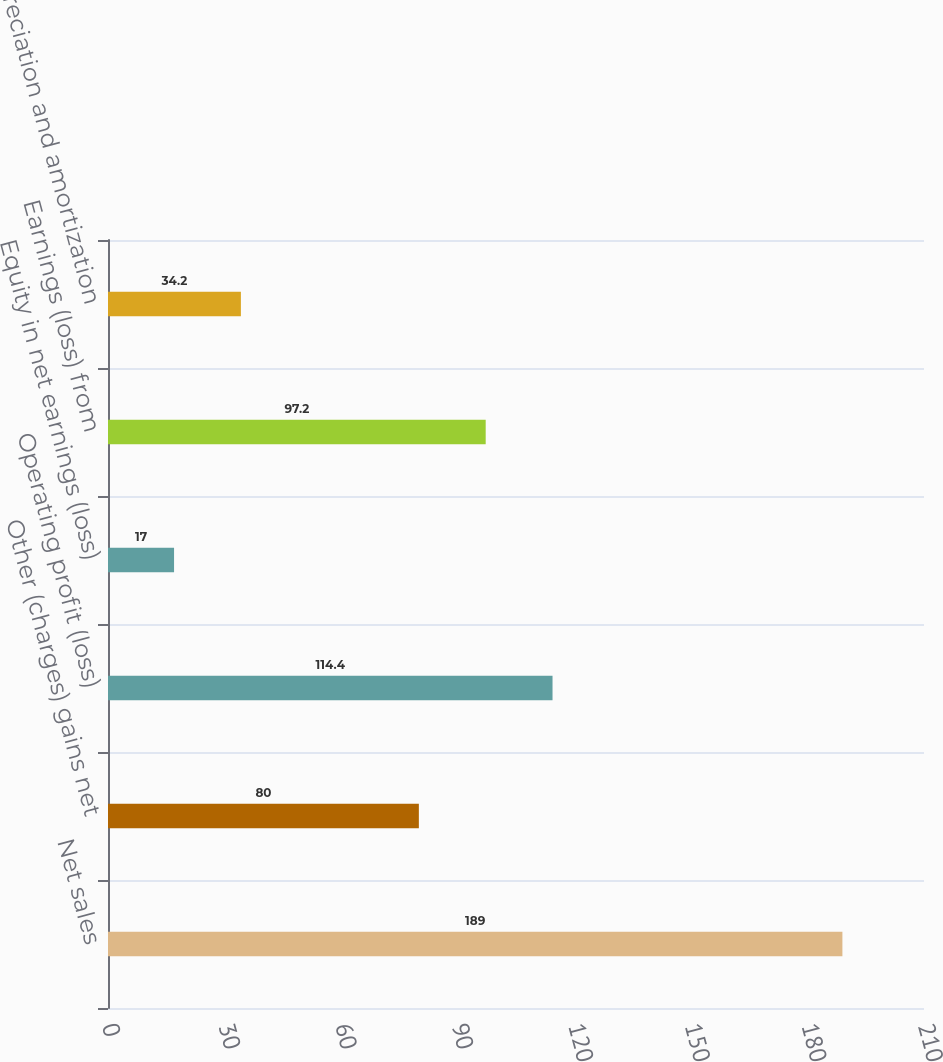<chart> <loc_0><loc_0><loc_500><loc_500><bar_chart><fcel>Net sales<fcel>Other (charges) gains net<fcel>Operating profit (loss)<fcel>Equity in net earnings (loss)<fcel>Earnings (loss) from<fcel>Depreciation and amortization<nl><fcel>189<fcel>80<fcel>114.4<fcel>17<fcel>97.2<fcel>34.2<nl></chart> 